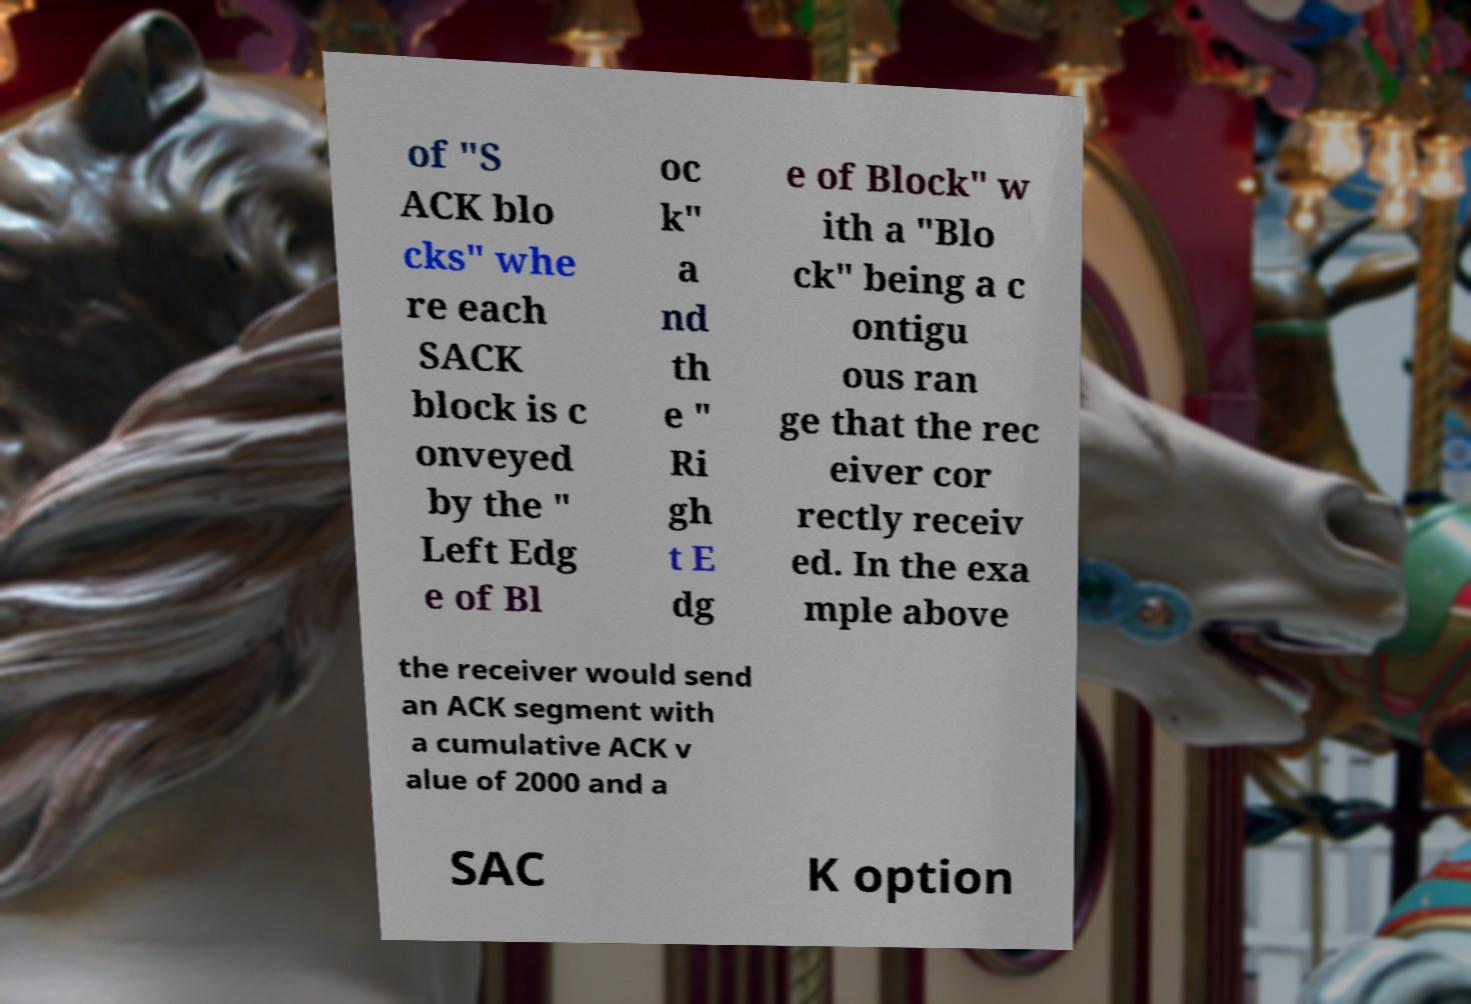There's text embedded in this image that I need extracted. Can you transcribe it verbatim? of "S ACK blo cks" whe re each SACK block is c onveyed by the " Left Edg e of Bl oc k" a nd th e " Ri gh t E dg e of Block" w ith a "Blo ck" being a c ontigu ous ran ge that the rec eiver cor rectly receiv ed. In the exa mple above the receiver would send an ACK segment with a cumulative ACK v alue of 2000 and a SAC K option 